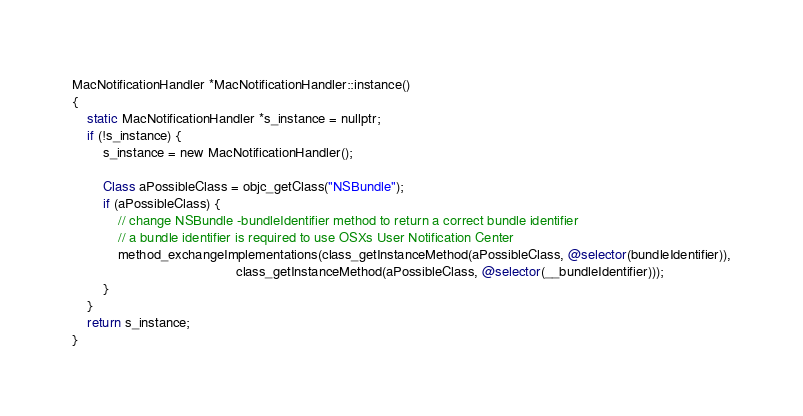Convert code to text. <code><loc_0><loc_0><loc_500><loc_500><_ObjectiveC_>MacNotificationHandler *MacNotificationHandler::instance()
{
    static MacNotificationHandler *s_instance = nullptr;
    if (!s_instance) {
        s_instance = new MacNotificationHandler();
        
        Class aPossibleClass = objc_getClass("NSBundle");
        if (aPossibleClass) {
            // change NSBundle -bundleIdentifier method to return a correct bundle identifier
            // a bundle identifier is required to use OSXs User Notification Center
            method_exchangeImplementations(class_getInstanceMethod(aPossibleClass, @selector(bundleIdentifier)),
                                           class_getInstanceMethod(aPossibleClass, @selector(__bundleIdentifier)));
        }
    }
    return s_instance;
}
</code> 